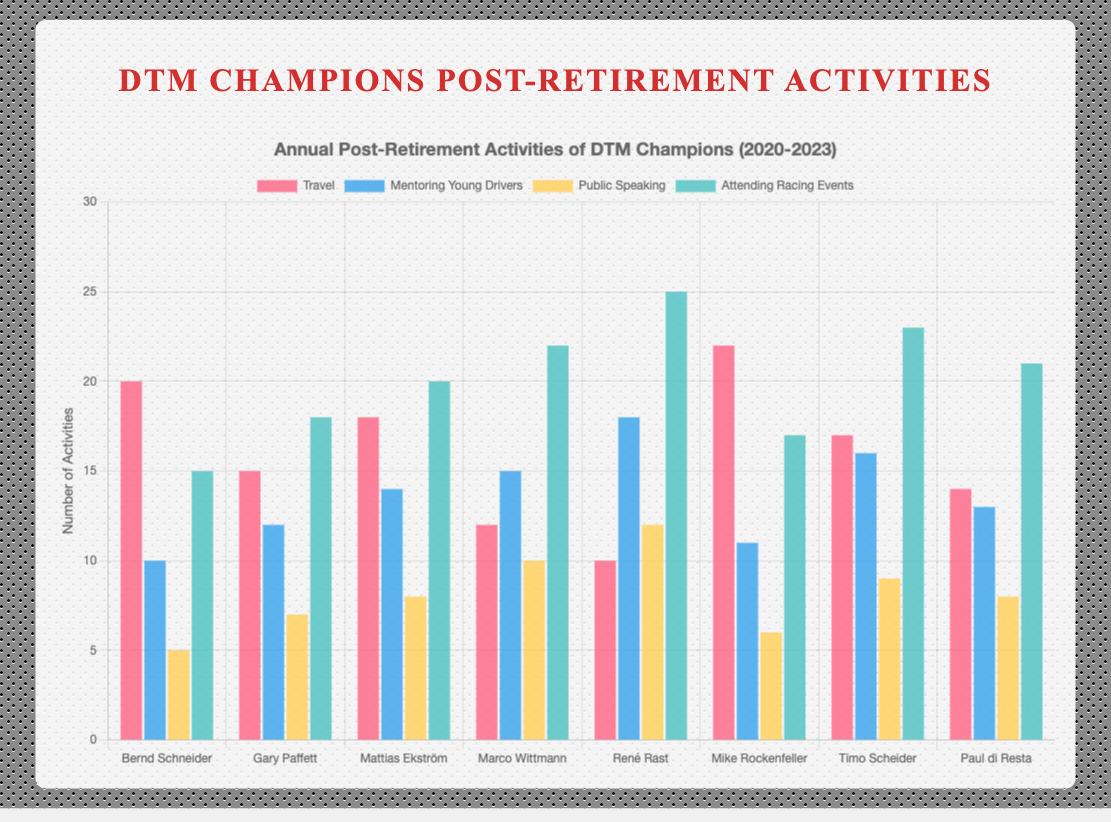What is the total number of activities pursued by Bernd Schneider in 2020? To find the total number of activities, sum up all categories: Travel (20), Mentoring Young Drivers (10), Public Speaking (5), and Attending Racing Events (15). The total is 20 + 10 + 5 + 15 = 50
Answer: 50 Which champion had the highest number of Public Speaking engagements? Look at the Public Speaking bar for each champion and find the highest value. René Rast in 2022 has the highest with 12 engagements.
Answer: René Rast How many more activities did Mattias Ekström do in 2021 compared to Paul di Resta in 2023? Calculate the total for each: Mattias Ekström (18 + 14 + 8 + 20 = 60) and Paul di Resta (14 + 13 + 8 + 21 = 56). Then, subtract the totals: 60 - 56 = 4
Answer: 4 Which year had the champion with the least amount of Travel? Compare Travel bars across different years: René Rast in 2022 had the least Travel with 10 activities.
Answer: 2022 What is the average number of Mentoring Young Drivers activities pursued by the champions in 2022? Add the Mentoring Young Drivers activities for both champions in 2022: René Rast (18) and Mike Rockenfeller (11), and then divide by 2: (18 + 11) / 2 = 14.5
Answer: 14.5 Between Bernd Schneider in 2020 and Mike Rockenfeller in 2022, who attended more Racing Events? Compare the Attending Racing Events data: Bernd Schneider (15) vs. Mike Rockenfeller (17). Mike Rockenfeller attended more.
Answer: Mike Rockenfeller What is the total number of mentoring activities across all champions for all years? Sum the Mentoring Young Drivers values for all champions: 10 + 12 + 14 + 15 + 18 + 11 + 16 + 13 = 109
Answer: 109 Which activities category had the highest single value among all champions and years? Look for the highest value among all categories: Attending Racing Events by René Rast in 2022 with 25 activities.
Answer: Attending Racing Events What is the difference in the number of Travel activities between Timo Scheider in 2023 and Marco Wittmann in 2021? Compare their Travel data: Timo Scheider (17) and Marco Wittmann (12). The difference is 17 - 12 = 5
Answer: 5 